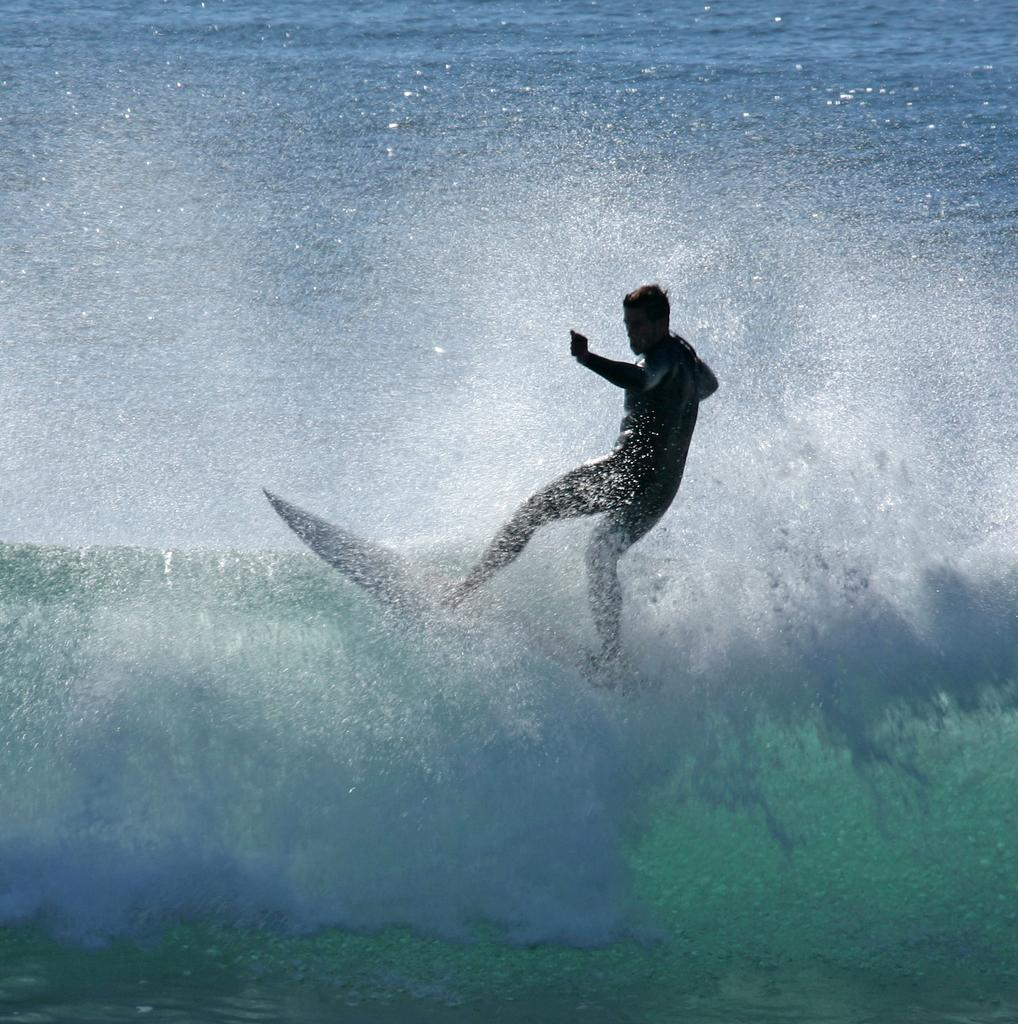What is the main subject in the foreground of the image? There is a man in the foreground of the image. What is the man doing in the image? The man is surfing on the water. What type of button can be seen on the kettle in the image? There is no kettle or button present in the image; it features a man surfing on the water. 